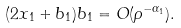<formula> <loc_0><loc_0><loc_500><loc_500>( 2 x _ { 1 } + b _ { 1 } ) b _ { 1 } = O ( \rho ^ { - \alpha _ { 1 } } ) .</formula> 